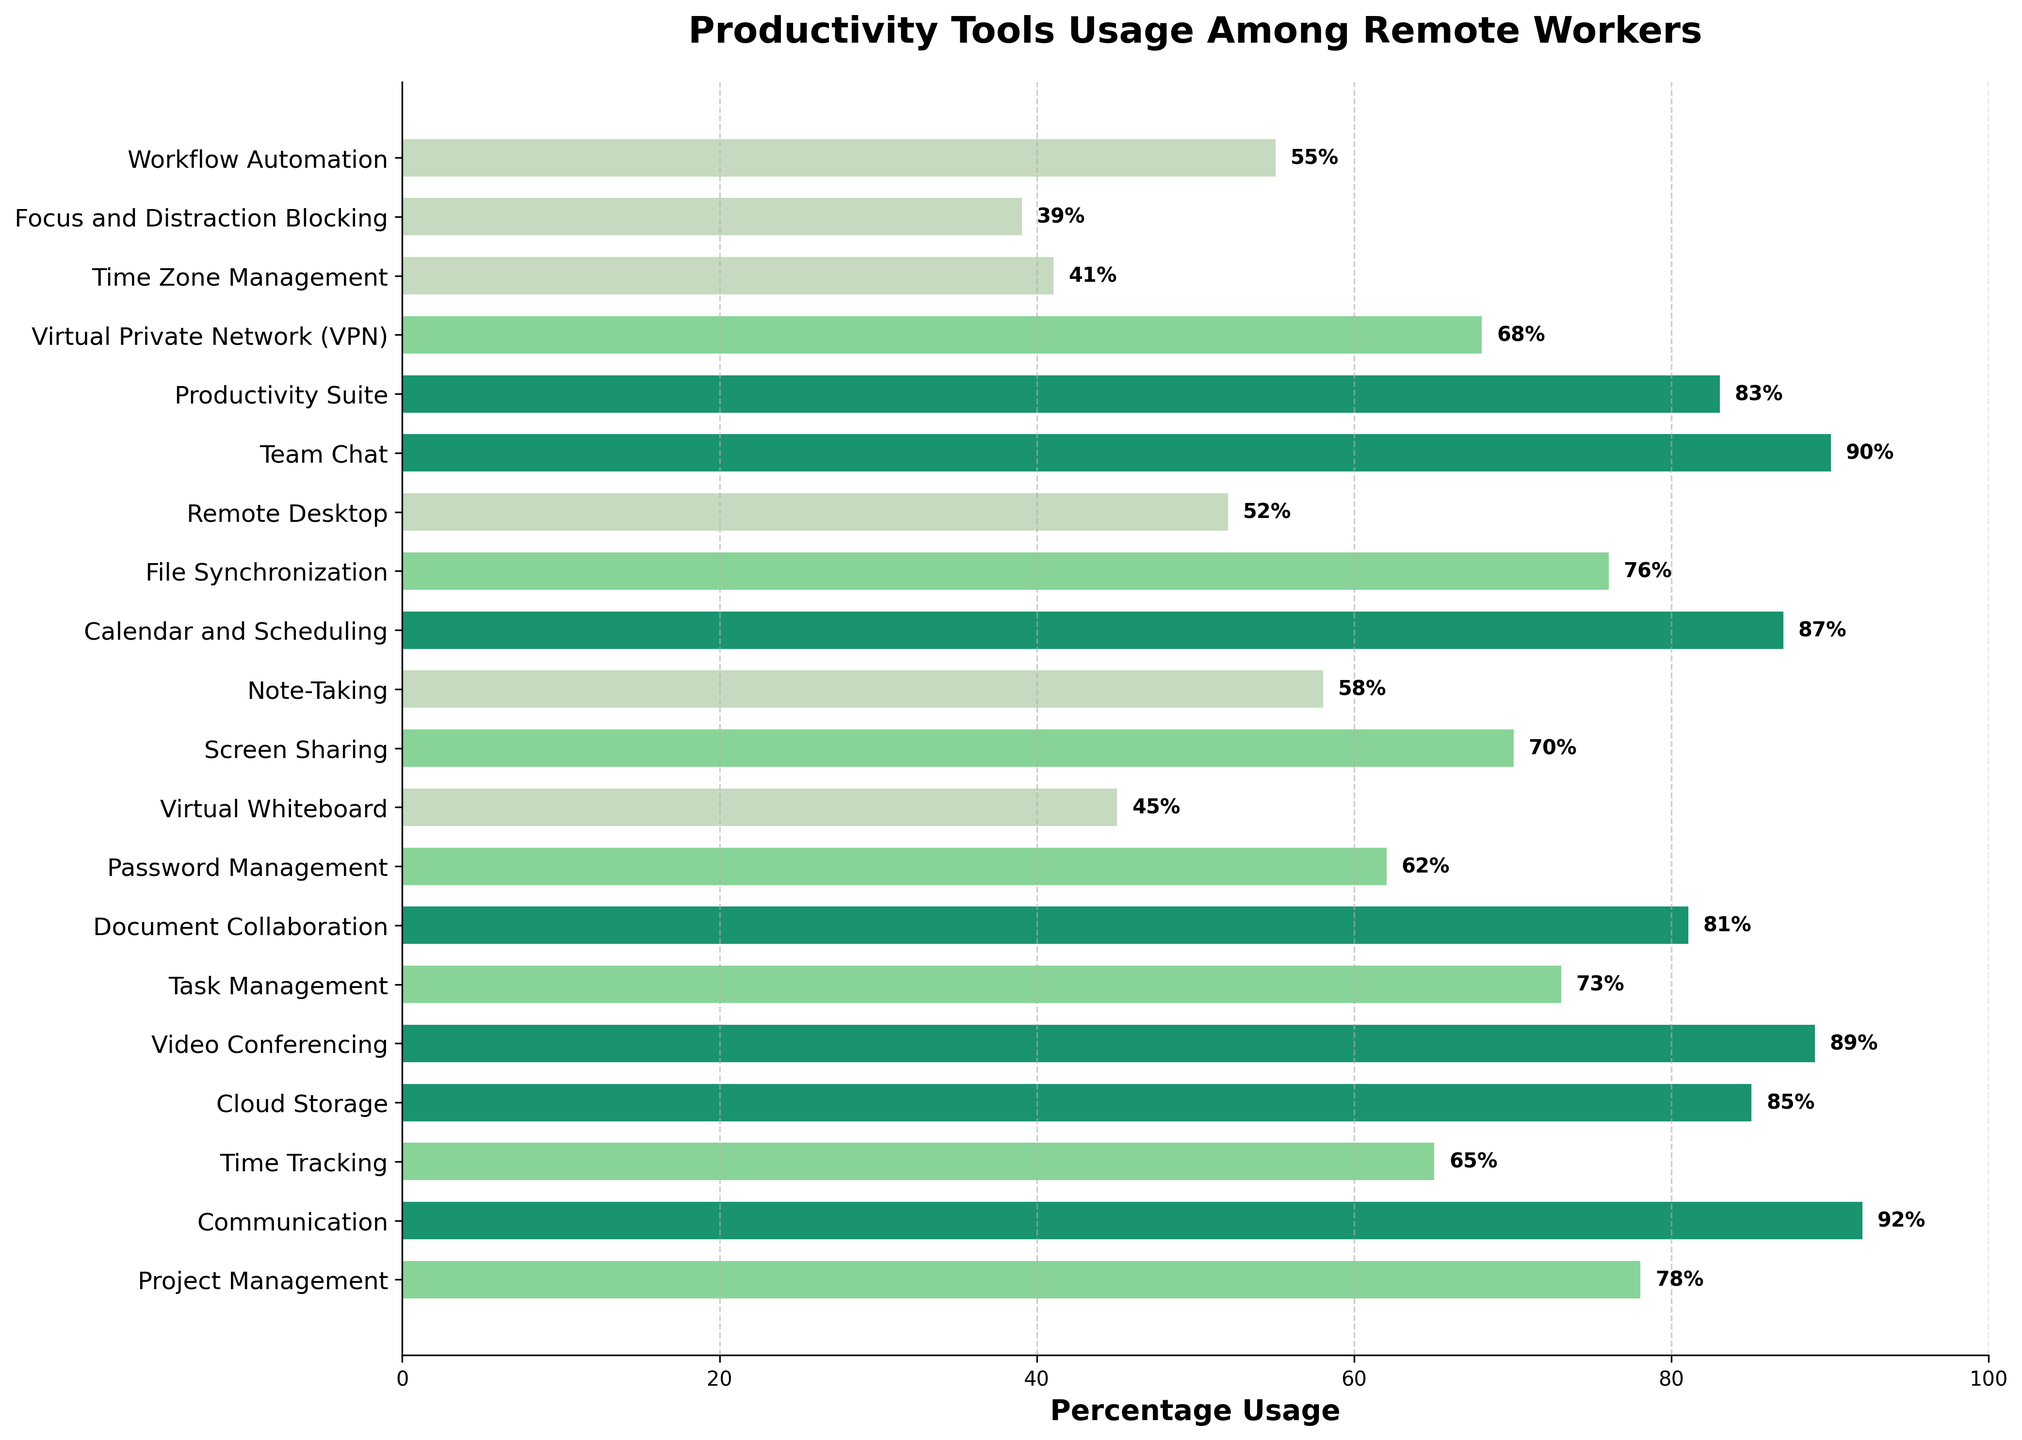Which tool has the highest usage percentage? The bar for Communication is the longest and reaches the highest percentage value of 92%
Answer: Communication What is the difference in usage percentage between Communication and Password Management tools? Communication has a usage percentage of 92%, and Password Management has 62%. The difference is 92% - 62% = 30%
Answer: 30% Which tools have a usage percentage greater than 80%? The tools with bars extending beyond the 80% mark are Communication (92%), Cloud Storage (85%), Video Conferencing (89%), Document Collaboration (81%), Calendar and Scheduling (87%), and Productivity Suite (83%)
Answer: Communication, Cloud Storage, Video Conferencing, Document Collaboration, Calendar and Scheduling, Productivity Suite What's the average usage percentage of Note-Taking, Task Management, and Screen Sharing tools? The percentages for Note-Taking, Task Management, and Screen Sharing are 58%, 73%, and 70%. The sum is 58 + 73 + 70 = 201, and their average is 201 / 3 = 67%
Answer: 67% Which tool is used less frequently, Virtual Whiteboard or Remote Desktop, and by how much? Virtual Whiteboard has a usage percentage of 45%, whereas Remote Desktop has 52%. The difference is 52% - 45% = 7%
Answer: Virtual Whiteboard by 7% What's the collective usage percentage for Project Management, Team Chat, and Video Conferencing tools? The percentages for Project Management, Team Chat, and Video Conferencing are 78%, 90%, and 89%. Summing them gives 78 + 90 + 89 = 257%
Answer: 257% Which tools fall below the 50% usage mark? The bars for Time Zone Management (41%) and Focus and Distraction Blocking (39%) do not extend beyond the 50% mark
Answer: Time Zone Management, Focus and Distraction Blocking 